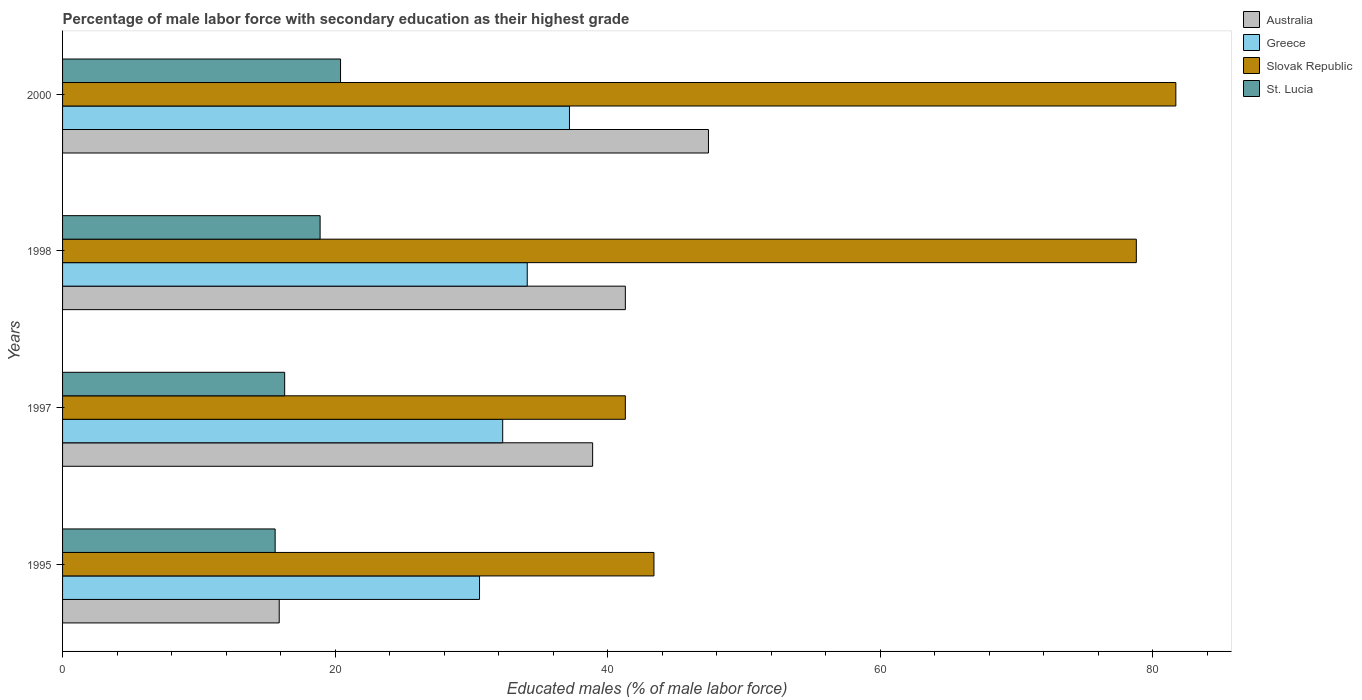How many different coloured bars are there?
Your response must be concise. 4. How many bars are there on the 1st tick from the top?
Offer a terse response. 4. How many bars are there on the 1st tick from the bottom?
Provide a succinct answer. 4. What is the label of the 3rd group of bars from the top?
Your response must be concise. 1997. What is the percentage of male labor force with secondary education in Australia in 2000?
Offer a very short reply. 47.4. Across all years, what is the maximum percentage of male labor force with secondary education in Greece?
Your answer should be compact. 37.2. Across all years, what is the minimum percentage of male labor force with secondary education in Australia?
Your response must be concise. 15.9. In which year was the percentage of male labor force with secondary education in Australia minimum?
Your answer should be very brief. 1995. What is the total percentage of male labor force with secondary education in Slovak Republic in the graph?
Ensure brevity in your answer.  245.2. What is the difference between the percentage of male labor force with secondary education in St. Lucia in 1997 and that in 1998?
Keep it short and to the point. -2.6. What is the difference between the percentage of male labor force with secondary education in Slovak Republic in 1998 and the percentage of male labor force with secondary education in Greece in 1997?
Provide a succinct answer. 46.5. What is the average percentage of male labor force with secondary education in Greece per year?
Give a very brief answer. 33.55. In the year 1995, what is the difference between the percentage of male labor force with secondary education in Australia and percentage of male labor force with secondary education in St. Lucia?
Offer a terse response. 0.3. What is the ratio of the percentage of male labor force with secondary education in Greece in 1995 to that in 2000?
Your response must be concise. 0.82. Is the difference between the percentage of male labor force with secondary education in Australia in 1997 and 1998 greater than the difference between the percentage of male labor force with secondary education in St. Lucia in 1997 and 1998?
Your answer should be compact. Yes. What is the difference between the highest and the second highest percentage of male labor force with secondary education in Greece?
Offer a terse response. 3.1. What is the difference between the highest and the lowest percentage of male labor force with secondary education in Australia?
Provide a short and direct response. 31.5. In how many years, is the percentage of male labor force with secondary education in Slovak Republic greater than the average percentage of male labor force with secondary education in Slovak Republic taken over all years?
Ensure brevity in your answer.  2. Is it the case that in every year, the sum of the percentage of male labor force with secondary education in Australia and percentage of male labor force with secondary education in St. Lucia is greater than the sum of percentage of male labor force with secondary education in Slovak Republic and percentage of male labor force with secondary education in Greece?
Your response must be concise. No. What does the 3rd bar from the top in 1995 represents?
Provide a short and direct response. Greece. What does the 3rd bar from the bottom in 1998 represents?
Your answer should be very brief. Slovak Republic. Is it the case that in every year, the sum of the percentage of male labor force with secondary education in St. Lucia and percentage of male labor force with secondary education in Slovak Republic is greater than the percentage of male labor force with secondary education in Greece?
Make the answer very short. Yes. Are all the bars in the graph horizontal?
Your response must be concise. Yes. Does the graph contain any zero values?
Keep it short and to the point. No. Does the graph contain grids?
Offer a terse response. No. How many legend labels are there?
Your answer should be compact. 4. How are the legend labels stacked?
Offer a terse response. Vertical. What is the title of the graph?
Make the answer very short. Percentage of male labor force with secondary education as their highest grade. Does "Uruguay" appear as one of the legend labels in the graph?
Offer a very short reply. No. What is the label or title of the X-axis?
Provide a succinct answer. Educated males (% of male labor force). What is the label or title of the Y-axis?
Your answer should be compact. Years. What is the Educated males (% of male labor force) in Australia in 1995?
Provide a succinct answer. 15.9. What is the Educated males (% of male labor force) of Greece in 1995?
Give a very brief answer. 30.6. What is the Educated males (% of male labor force) in Slovak Republic in 1995?
Offer a very short reply. 43.4. What is the Educated males (% of male labor force) in St. Lucia in 1995?
Your answer should be compact. 15.6. What is the Educated males (% of male labor force) in Australia in 1997?
Provide a succinct answer. 38.9. What is the Educated males (% of male labor force) in Greece in 1997?
Make the answer very short. 32.3. What is the Educated males (% of male labor force) of Slovak Republic in 1997?
Your answer should be very brief. 41.3. What is the Educated males (% of male labor force) in St. Lucia in 1997?
Your answer should be very brief. 16.3. What is the Educated males (% of male labor force) in Australia in 1998?
Make the answer very short. 41.3. What is the Educated males (% of male labor force) in Greece in 1998?
Your answer should be very brief. 34.1. What is the Educated males (% of male labor force) of Slovak Republic in 1998?
Your response must be concise. 78.8. What is the Educated males (% of male labor force) of St. Lucia in 1998?
Give a very brief answer. 18.9. What is the Educated males (% of male labor force) of Australia in 2000?
Your answer should be very brief. 47.4. What is the Educated males (% of male labor force) of Greece in 2000?
Give a very brief answer. 37.2. What is the Educated males (% of male labor force) of Slovak Republic in 2000?
Keep it short and to the point. 81.7. What is the Educated males (% of male labor force) of St. Lucia in 2000?
Ensure brevity in your answer.  20.4. Across all years, what is the maximum Educated males (% of male labor force) of Australia?
Keep it short and to the point. 47.4. Across all years, what is the maximum Educated males (% of male labor force) of Greece?
Give a very brief answer. 37.2. Across all years, what is the maximum Educated males (% of male labor force) of Slovak Republic?
Your answer should be compact. 81.7. Across all years, what is the maximum Educated males (% of male labor force) in St. Lucia?
Your answer should be very brief. 20.4. Across all years, what is the minimum Educated males (% of male labor force) in Australia?
Offer a terse response. 15.9. Across all years, what is the minimum Educated males (% of male labor force) in Greece?
Give a very brief answer. 30.6. Across all years, what is the minimum Educated males (% of male labor force) of Slovak Republic?
Offer a terse response. 41.3. Across all years, what is the minimum Educated males (% of male labor force) of St. Lucia?
Ensure brevity in your answer.  15.6. What is the total Educated males (% of male labor force) of Australia in the graph?
Ensure brevity in your answer.  143.5. What is the total Educated males (% of male labor force) of Greece in the graph?
Keep it short and to the point. 134.2. What is the total Educated males (% of male labor force) of Slovak Republic in the graph?
Your response must be concise. 245.2. What is the total Educated males (% of male labor force) in St. Lucia in the graph?
Provide a succinct answer. 71.2. What is the difference between the Educated males (% of male labor force) in Greece in 1995 and that in 1997?
Make the answer very short. -1.7. What is the difference between the Educated males (% of male labor force) in St. Lucia in 1995 and that in 1997?
Your answer should be compact. -0.7. What is the difference between the Educated males (% of male labor force) in Australia in 1995 and that in 1998?
Provide a succinct answer. -25.4. What is the difference between the Educated males (% of male labor force) in Greece in 1995 and that in 1998?
Your answer should be compact. -3.5. What is the difference between the Educated males (% of male labor force) of Slovak Republic in 1995 and that in 1998?
Offer a terse response. -35.4. What is the difference between the Educated males (% of male labor force) in St. Lucia in 1995 and that in 1998?
Ensure brevity in your answer.  -3.3. What is the difference between the Educated males (% of male labor force) in Australia in 1995 and that in 2000?
Your answer should be compact. -31.5. What is the difference between the Educated males (% of male labor force) in Slovak Republic in 1995 and that in 2000?
Keep it short and to the point. -38.3. What is the difference between the Educated males (% of male labor force) in Greece in 1997 and that in 1998?
Your answer should be compact. -1.8. What is the difference between the Educated males (% of male labor force) in Slovak Republic in 1997 and that in 1998?
Give a very brief answer. -37.5. What is the difference between the Educated males (% of male labor force) of St. Lucia in 1997 and that in 1998?
Your answer should be very brief. -2.6. What is the difference between the Educated males (% of male labor force) of Australia in 1997 and that in 2000?
Provide a short and direct response. -8.5. What is the difference between the Educated males (% of male labor force) in Slovak Republic in 1997 and that in 2000?
Make the answer very short. -40.4. What is the difference between the Educated males (% of male labor force) in St. Lucia in 1997 and that in 2000?
Give a very brief answer. -4.1. What is the difference between the Educated males (% of male labor force) in Australia in 1998 and that in 2000?
Offer a terse response. -6.1. What is the difference between the Educated males (% of male labor force) of Slovak Republic in 1998 and that in 2000?
Your answer should be compact. -2.9. What is the difference between the Educated males (% of male labor force) of St. Lucia in 1998 and that in 2000?
Offer a terse response. -1.5. What is the difference between the Educated males (% of male labor force) of Australia in 1995 and the Educated males (% of male labor force) of Greece in 1997?
Provide a short and direct response. -16.4. What is the difference between the Educated males (% of male labor force) of Australia in 1995 and the Educated males (% of male labor force) of Slovak Republic in 1997?
Keep it short and to the point. -25.4. What is the difference between the Educated males (% of male labor force) of Greece in 1995 and the Educated males (% of male labor force) of Slovak Republic in 1997?
Make the answer very short. -10.7. What is the difference between the Educated males (% of male labor force) of Greece in 1995 and the Educated males (% of male labor force) of St. Lucia in 1997?
Provide a short and direct response. 14.3. What is the difference between the Educated males (% of male labor force) of Slovak Republic in 1995 and the Educated males (% of male labor force) of St. Lucia in 1997?
Give a very brief answer. 27.1. What is the difference between the Educated males (% of male labor force) of Australia in 1995 and the Educated males (% of male labor force) of Greece in 1998?
Provide a succinct answer. -18.2. What is the difference between the Educated males (% of male labor force) of Australia in 1995 and the Educated males (% of male labor force) of Slovak Republic in 1998?
Your answer should be compact. -62.9. What is the difference between the Educated males (% of male labor force) in Greece in 1995 and the Educated males (% of male labor force) in Slovak Republic in 1998?
Make the answer very short. -48.2. What is the difference between the Educated males (% of male labor force) of Australia in 1995 and the Educated males (% of male labor force) of Greece in 2000?
Provide a short and direct response. -21.3. What is the difference between the Educated males (% of male labor force) in Australia in 1995 and the Educated males (% of male labor force) in Slovak Republic in 2000?
Keep it short and to the point. -65.8. What is the difference between the Educated males (% of male labor force) of Australia in 1995 and the Educated males (% of male labor force) of St. Lucia in 2000?
Ensure brevity in your answer.  -4.5. What is the difference between the Educated males (% of male labor force) of Greece in 1995 and the Educated males (% of male labor force) of Slovak Republic in 2000?
Provide a short and direct response. -51.1. What is the difference between the Educated males (% of male labor force) in Australia in 1997 and the Educated males (% of male labor force) in Greece in 1998?
Give a very brief answer. 4.8. What is the difference between the Educated males (% of male labor force) in Australia in 1997 and the Educated males (% of male labor force) in Slovak Republic in 1998?
Your answer should be very brief. -39.9. What is the difference between the Educated males (% of male labor force) in Australia in 1997 and the Educated males (% of male labor force) in St. Lucia in 1998?
Ensure brevity in your answer.  20. What is the difference between the Educated males (% of male labor force) in Greece in 1997 and the Educated males (% of male labor force) in Slovak Republic in 1998?
Your response must be concise. -46.5. What is the difference between the Educated males (% of male labor force) of Slovak Republic in 1997 and the Educated males (% of male labor force) of St. Lucia in 1998?
Provide a short and direct response. 22.4. What is the difference between the Educated males (% of male labor force) in Australia in 1997 and the Educated males (% of male labor force) in Slovak Republic in 2000?
Offer a terse response. -42.8. What is the difference between the Educated males (% of male labor force) in Greece in 1997 and the Educated males (% of male labor force) in Slovak Republic in 2000?
Ensure brevity in your answer.  -49.4. What is the difference between the Educated males (% of male labor force) of Greece in 1997 and the Educated males (% of male labor force) of St. Lucia in 2000?
Offer a terse response. 11.9. What is the difference between the Educated males (% of male labor force) in Slovak Republic in 1997 and the Educated males (% of male labor force) in St. Lucia in 2000?
Keep it short and to the point. 20.9. What is the difference between the Educated males (% of male labor force) of Australia in 1998 and the Educated males (% of male labor force) of Slovak Republic in 2000?
Ensure brevity in your answer.  -40.4. What is the difference between the Educated males (% of male labor force) in Australia in 1998 and the Educated males (% of male labor force) in St. Lucia in 2000?
Provide a short and direct response. 20.9. What is the difference between the Educated males (% of male labor force) of Greece in 1998 and the Educated males (% of male labor force) of Slovak Republic in 2000?
Give a very brief answer. -47.6. What is the difference between the Educated males (% of male labor force) of Greece in 1998 and the Educated males (% of male labor force) of St. Lucia in 2000?
Make the answer very short. 13.7. What is the difference between the Educated males (% of male labor force) in Slovak Republic in 1998 and the Educated males (% of male labor force) in St. Lucia in 2000?
Your response must be concise. 58.4. What is the average Educated males (% of male labor force) in Australia per year?
Ensure brevity in your answer.  35.88. What is the average Educated males (% of male labor force) in Greece per year?
Provide a short and direct response. 33.55. What is the average Educated males (% of male labor force) in Slovak Republic per year?
Ensure brevity in your answer.  61.3. What is the average Educated males (% of male labor force) in St. Lucia per year?
Offer a very short reply. 17.8. In the year 1995, what is the difference between the Educated males (% of male labor force) in Australia and Educated males (% of male labor force) in Greece?
Your response must be concise. -14.7. In the year 1995, what is the difference between the Educated males (% of male labor force) of Australia and Educated males (% of male labor force) of Slovak Republic?
Ensure brevity in your answer.  -27.5. In the year 1995, what is the difference between the Educated males (% of male labor force) of Greece and Educated males (% of male labor force) of Slovak Republic?
Offer a very short reply. -12.8. In the year 1995, what is the difference between the Educated males (% of male labor force) in Greece and Educated males (% of male labor force) in St. Lucia?
Make the answer very short. 15. In the year 1995, what is the difference between the Educated males (% of male labor force) of Slovak Republic and Educated males (% of male labor force) of St. Lucia?
Make the answer very short. 27.8. In the year 1997, what is the difference between the Educated males (% of male labor force) in Australia and Educated males (% of male labor force) in Greece?
Provide a succinct answer. 6.6. In the year 1997, what is the difference between the Educated males (% of male labor force) of Australia and Educated males (% of male labor force) of Slovak Republic?
Keep it short and to the point. -2.4. In the year 1997, what is the difference between the Educated males (% of male labor force) of Australia and Educated males (% of male labor force) of St. Lucia?
Provide a short and direct response. 22.6. In the year 1997, what is the difference between the Educated males (% of male labor force) of Greece and Educated males (% of male labor force) of Slovak Republic?
Provide a short and direct response. -9. In the year 1997, what is the difference between the Educated males (% of male labor force) in Greece and Educated males (% of male labor force) in St. Lucia?
Your response must be concise. 16. In the year 1997, what is the difference between the Educated males (% of male labor force) of Slovak Republic and Educated males (% of male labor force) of St. Lucia?
Ensure brevity in your answer.  25. In the year 1998, what is the difference between the Educated males (% of male labor force) in Australia and Educated males (% of male labor force) in Greece?
Give a very brief answer. 7.2. In the year 1998, what is the difference between the Educated males (% of male labor force) in Australia and Educated males (% of male labor force) in Slovak Republic?
Your answer should be compact. -37.5. In the year 1998, what is the difference between the Educated males (% of male labor force) in Australia and Educated males (% of male labor force) in St. Lucia?
Your answer should be very brief. 22.4. In the year 1998, what is the difference between the Educated males (% of male labor force) of Greece and Educated males (% of male labor force) of Slovak Republic?
Offer a terse response. -44.7. In the year 1998, what is the difference between the Educated males (% of male labor force) of Slovak Republic and Educated males (% of male labor force) of St. Lucia?
Give a very brief answer. 59.9. In the year 2000, what is the difference between the Educated males (% of male labor force) of Australia and Educated males (% of male labor force) of Greece?
Ensure brevity in your answer.  10.2. In the year 2000, what is the difference between the Educated males (% of male labor force) in Australia and Educated males (% of male labor force) in Slovak Republic?
Provide a succinct answer. -34.3. In the year 2000, what is the difference between the Educated males (% of male labor force) in Australia and Educated males (% of male labor force) in St. Lucia?
Give a very brief answer. 27. In the year 2000, what is the difference between the Educated males (% of male labor force) in Greece and Educated males (% of male labor force) in Slovak Republic?
Keep it short and to the point. -44.5. In the year 2000, what is the difference between the Educated males (% of male labor force) of Greece and Educated males (% of male labor force) of St. Lucia?
Keep it short and to the point. 16.8. In the year 2000, what is the difference between the Educated males (% of male labor force) in Slovak Republic and Educated males (% of male labor force) in St. Lucia?
Provide a succinct answer. 61.3. What is the ratio of the Educated males (% of male labor force) in Australia in 1995 to that in 1997?
Provide a succinct answer. 0.41. What is the ratio of the Educated males (% of male labor force) in Greece in 1995 to that in 1997?
Give a very brief answer. 0.95. What is the ratio of the Educated males (% of male labor force) in Slovak Republic in 1995 to that in 1997?
Make the answer very short. 1.05. What is the ratio of the Educated males (% of male labor force) of St. Lucia in 1995 to that in 1997?
Provide a short and direct response. 0.96. What is the ratio of the Educated males (% of male labor force) of Australia in 1995 to that in 1998?
Provide a succinct answer. 0.39. What is the ratio of the Educated males (% of male labor force) in Greece in 1995 to that in 1998?
Ensure brevity in your answer.  0.9. What is the ratio of the Educated males (% of male labor force) in Slovak Republic in 1995 to that in 1998?
Ensure brevity in your answer.  0.55. What is the ratio of the Educated males (% of male labor force) in St. Lucia in 1995 to that in 1998?
Your answer should be compact. 0.83. What is the ratio of the Educated males (% of male labor force) in Australia in 1995 to that in 2000?
Your response must be concise. 0.34. What is the ratio of the Educated males (% of male labor force) in Greece in 1995 to that in 2000?
Your response must be concise. 0.82. What is the ratio of the Educated males (% of male labor force) in Slovak Republic in 1995 to that in 2000?
Keep it short and to the point. 0.53. What is the ratio of the Educated males (% of male labor force) of St. Lucia in 1995 to that in 2000?
Your response must be concise. 0.76. What is the ratio of the Educated males (% of male labor force) of Australia in 1997 to that in 1998?
Provide a succinct answer. 0.94. What is the ratio of the Educated males (% of male labor force) in Greece in 1997 to that in 1998?
Your answer should be compact. 0.95. What is the ratio of the Educated males (% of male labor force) in Slovak Republic in 1997 to that in 1998?
Your answer should be compact. 0.52. What is the ratio of the Educated males (% of male labor force) in St. Lucia in 1997 to that in 1998?
Your response must be concise. 0.86. What is the ratio of the Educated males (% of male labor force) of Australia in 1997 to that in 2000?
Provide a short and direct response. 0.82. What is the ratio of the Educated males (% of male labor force) in Greece in 1997 to that in 2000?
Your answer should be compact. 0.87. What is the ratio of the Educated males (% of male labor force) of Slovak Republic in 1997 to that in 2000?
Give a very brief answer. 0.51. What is the ratio of the Educated males (% of male labor force) in St. Lucia in 1997 to that in 2000?
Keep it short and to the point. 0.8. What is the ratio of the Educated males (% of male labor force) in Australia in 1998 to that in 2000?
Offer a very short reply. 0.87. What is the ratio of the Educated males (% of male labor force) of Greece in 1998 to that in 2000?
Make the answer very short. 0.92. What is the ratio of the Educated males (% of male labor force) in Slovak Republic in 1998 to that in 2000?
Make the answer very short. 0.96. What is the ratio of the Educated males (% of male labor force) in St. Lucia in 1998 to that in 2000?
Offer a terse response. 0.93. What is the difference between the highest and the second highest Educated males (% of male labor force) in Australia?
Offer a very short reply. 6.1. What is the difference between the highest and the second highest Educated males (% of male labor force) of Greece?
Your response must be concise. 3.1. What is the difference between the highest and the second highest Educated males (% of male labor force) of Slovak Republic?
Offer a very short reply. 2.9. What is the difference between the highest and the second highest Educated males (% of male labor force) of St. Lucia?
Provide a succinct answer. 1.5. What is the difference between the highest and the lowest Educated males (% of male labor force) of Australia?
Provide a succinct answer. 31.5. What is the difference between the highest and the lowest Educated males (% of male labor force) of Greece?
Make the answer very short. 6.6. What is the difference between the highest and the lowest Educated males (% of male labor force) in Slovak Republic?
Your answer should be compact. 40.4. What is the difference between the highest and the lowest Educated males (% of male labor force) of St. Lucia?
Provide a succinct answer. 4.8. 